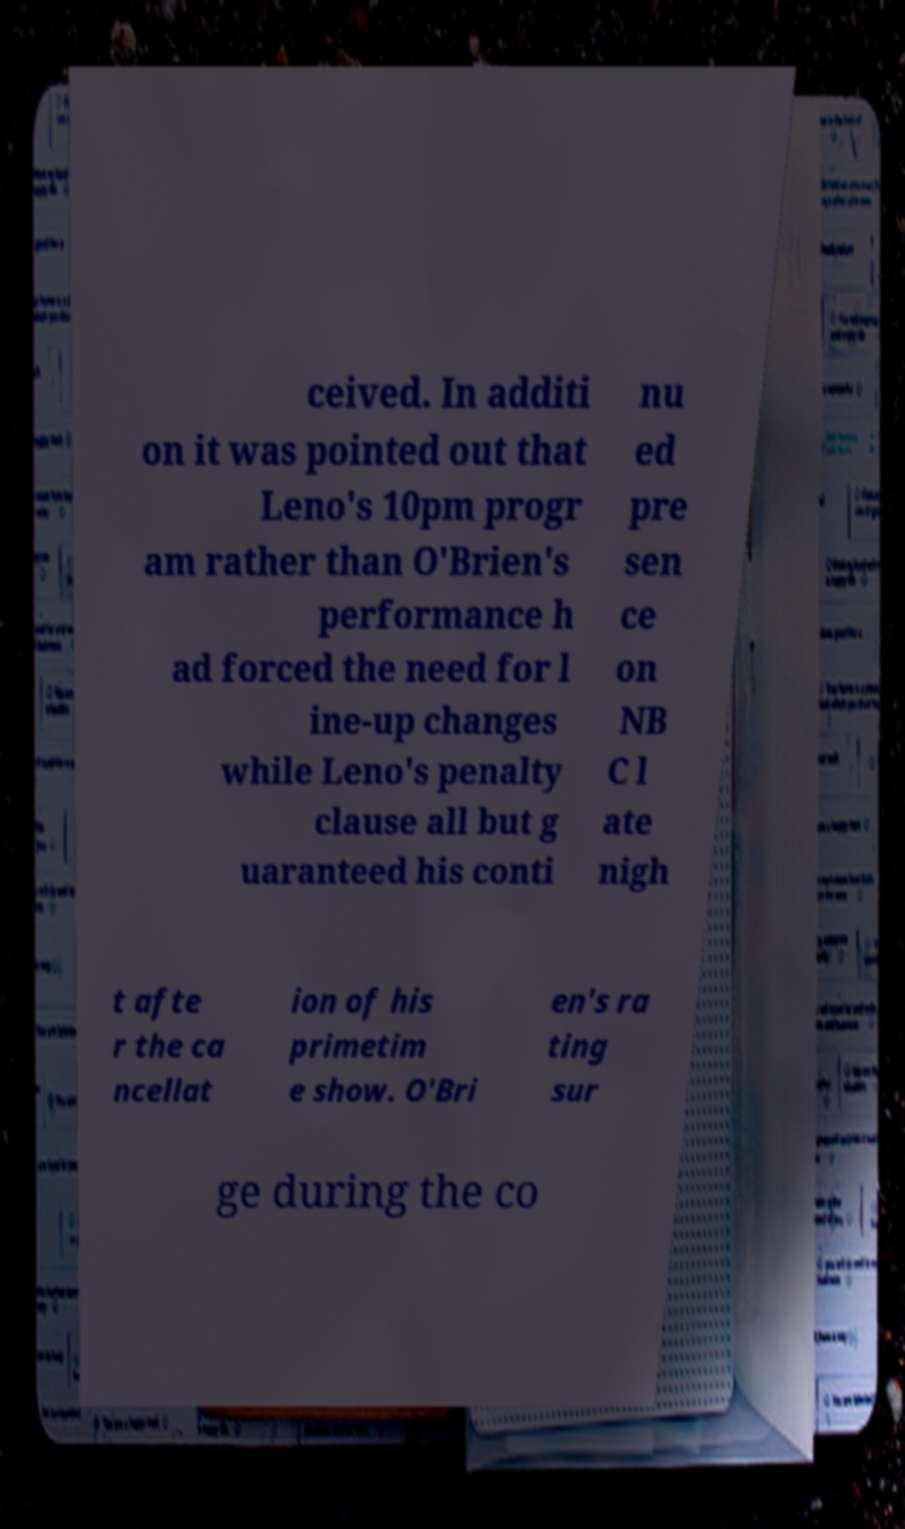Please identify and transcribe the text found in this image. ceived. In additi on it was pointed out that Leno's 10pm progr am rather than O'Brien's performance h ad forced the need for l ine-up changes while Leno's penalty clause all but g uaranteed his conti nu ed pre sen ce on NB C l ate nigh t afte r the ca ncellat ion of his primetim e show. O'Bri en's ra ting sur ge during the co 